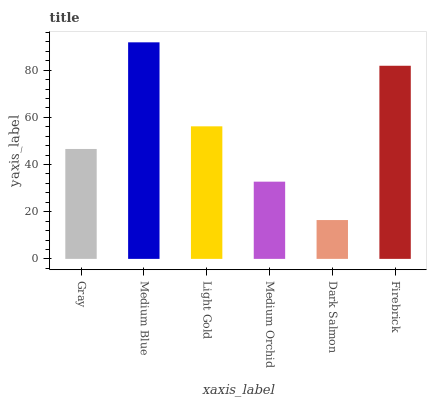Is Dark Salmon the minimum?
Answer yes or no. Yes. Is Medium Blue the maximum?
Answer yes or no. Yes. Is Light Gold the minimum?
Answer yes or no. No. Is Light Gold the maximum?
Answer yes or no. No. Is Medium Blue greater than Light Gold?
Answer yes or no. Yes. Is Light Gold less than Medium Blue?
Answer yes or no. Yes. Is Light Gold greater than Medium Blue?
Answer yes or no. No. Is Medium Blue less than Light Gold?
Answer yes or no. No. Is Light Gold the high median?
Answer yes or no. Yes. Is Gray the low median?
Answer yes or no. Yes. Is Medium Orchid the high median?
Answer yes or no. No. Is Light Gold the low median?
Answer yes or no. No. 